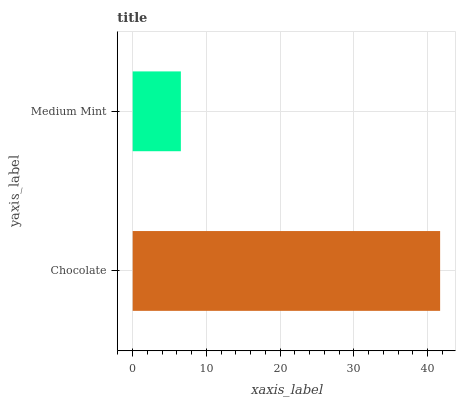Is Medium Mint the minimum?
Answer yes or no. Yes. Is Chocolate the maximum?
Answer yes or no. Yes. Is Medium Mint the maximum?
Answer yes or no. No. Is Chocolate greater than Medium Mint?
Answer yes or no. Yes. Is Medium Mint less than Chocolate?
Answer yes or no. Yes. Is Medium Mint greater than Chocolate?
Answer yes or no. No. Is Chocolate less than Medium Mint?
Answer yes or no. No. Is Chocolate the high median?
Answer yes or no. Yes. Is Medium Mint the low median?
Answer yes or no. Yes. Is Medium Mint the high median?
Answer yes or no. No. Is Chocolate the low median?
Answer yes or no. No. 